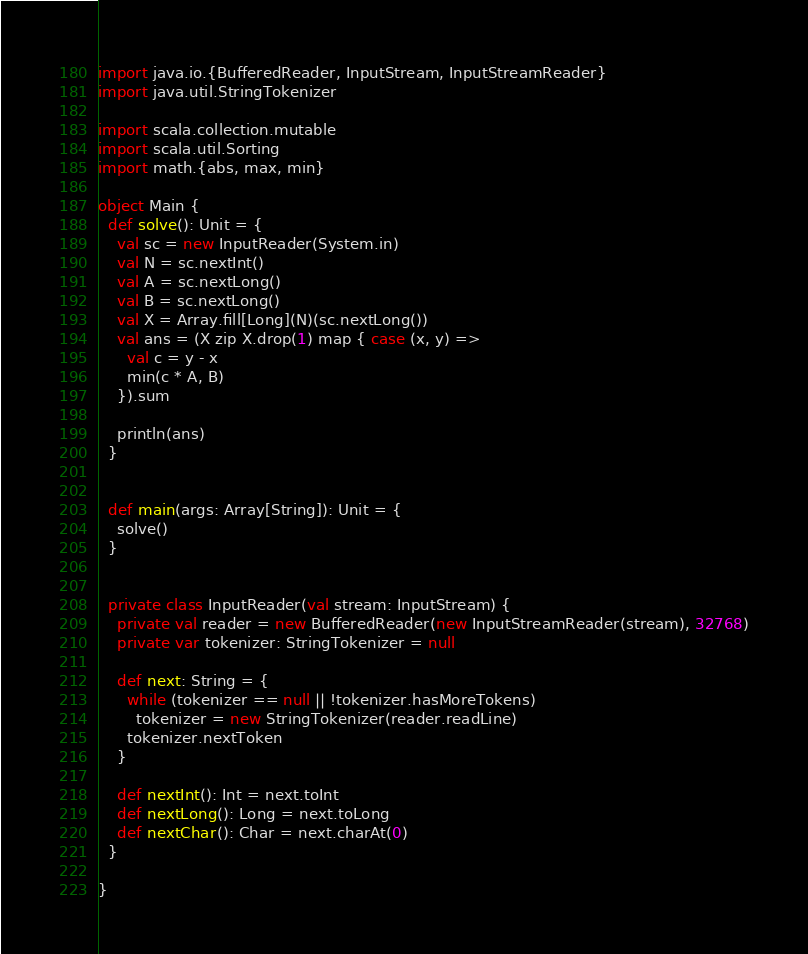<code> <loc_0><loc_0><loc_500><loc_500><_Scala_>import java.io.{BufferedReader, InputStream, InputStreamReader}
import java.util.StringTokenizer

import scala.collection.mutable
import scala.util.Sorting
import math.{abs, max, min}

object Main {
  def solve(): Unit = {
    val sc = new InputReader(System.in)
    val N = sc.nextInt()
    val A = sc.nextLong()
    val B = sc.nextLong()
    val X = Array.fill[Long](N)(sc.nextLong())
    val ans = (X zip X.drop(1) map { case (x, y) =>
      val c = y - x
      min(c * A, B)
    }).sum

    println(ans)
  }


  def main(args: Array[String]): Unit = {
    solve()
  }


  private class InputReader(val stream: InputStream) {
    private val reader = new BufferedReader(new InputStreamReader(stream), 32768)
    private var tokenizer: StringTokenizer = null

    def next: String = {
      while (tokenizer == null || !tokenizer.hasMoreTokens)
        tokenizer = new StringTokenizer(reader.readLine)
      tokenizer.nextToken
    }

    def nextInt(): Int = next.toInt
    def nextLong(): Long = next.toLong
    def nextChar(): Char = next.charAt(0)
  }

}
</code> 